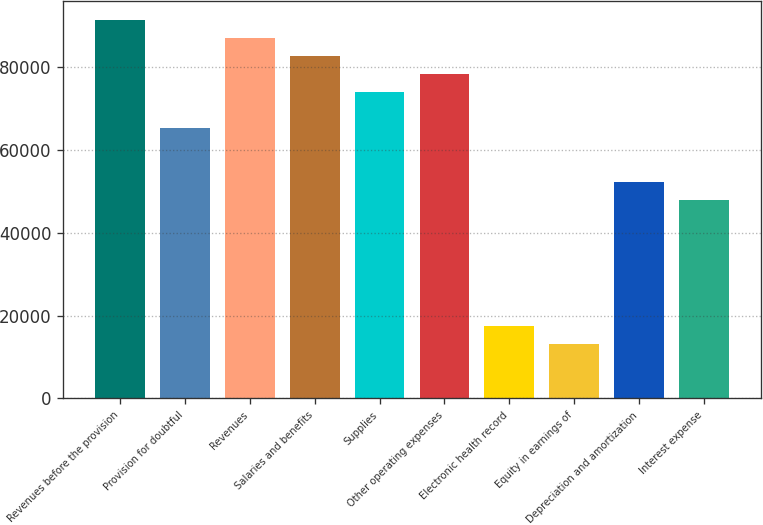Convert chart. <chart><loc_0><loc_0><loc_500><loc_500><bar_chart><fcel>Revenues before the provision<fcel>Provision for doubtful<fcel>Revenues<fcel>Salaries and benefits<fcel>Supplies<fcel>Other operating expenses<fcel>Electronic health record<fcel>Equity in earnings of<fcel>Depreciation and amortization<fcel>Interest expense<nl><fcel>91535.6<fcel>65384<fcel>87177<fcel>82818.4<fcel>74101.2<fcel>78459.8<fcel>17439.4<fcel>13080.8<fcel>52308.2<fcel>47949.6<nl></chart> 